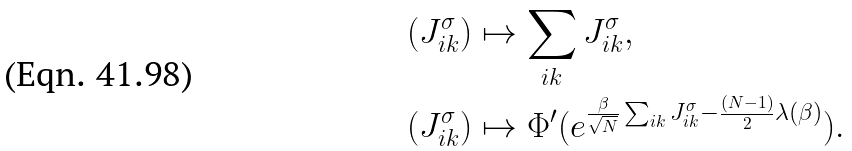<formula> <loc_0><loc_0><loc_500><loc_500>( J ^ { \sigma } _ { i k } ) & \mapsto \sum _ { i k } J ^ { \sigma } _ { i k } , \\ ( J ^ { \sigma } _ { i k } ) & \mapsto \Phi ^ { \prime } ( e ^ { \frac { \beta } { \sqrt { N } } \sum _ { i k } J ^ { \sigma } _ { i k } - \frac { ( N - 1 ) } { 2 } \lambda ( \beta ) } ) .</formula> 